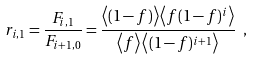<formula> <loc_0><loc_0><loc_500><loc_500>r _ { i , 1 } = \frac { F _ { i , 1 } } { F _ { i + 1 , 0 } } = \frac { \left < ( 1 - f ) \right > \left < f ( 1 - f ) ^ { i } \right > } { \left < f \right > \left < ( 1 - f ) ^ { i + 1 } \right > } \ ,</formula> 